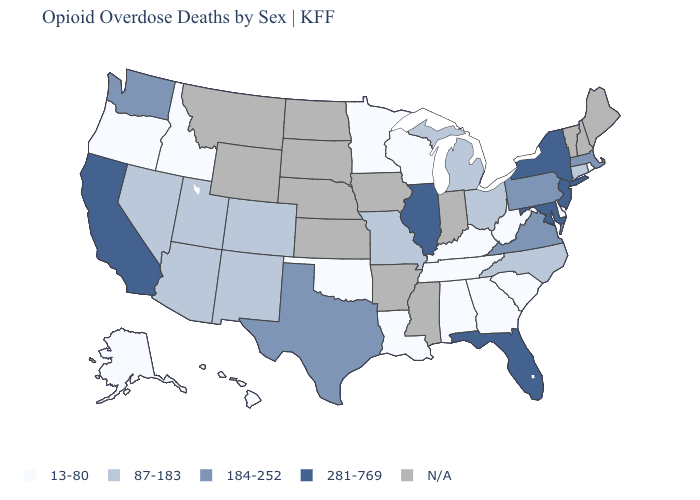What is the value of Minnesota?
Give a very brief answer. 13-80. How many symbols are there in the legend?
Write a very short answer. 5. What is the lowest value in the West?
Answer briefly. 13-80. Among the states that border New Jersey , which have the highest value?
Short answer required. New York. What is the highest value in the USA?
Short answer required. 281-769. What is the value of Arizona?
Keep it brief. 87-183. Name the states that have a value in the range 13-80?
Concise answer only. Alabama, Alaska, Delaware, Georgia, Hawaii, Idaho, Kentucky, Louisiana, Minnesota, Oklahoma, Oregon, Rhode Island, South Carolina, Tennessee, West Virginia, Wisconsin. Name the states that have a value in the range 184-252?
Short answer required. Massachusetts, Pennsylvania, Texas, Virginia, Washington. Name the states that have a value in the range N/A?
Quick response, please. Arkansas, Indiana, Iowa, Kansas, Maine, Mississippi, Montana, Nebraska, New Hampshire, North Dakota, South Dakota, Vermont, Wyoming. Does California have the highest value in the West?
Write a very short answer. Yes. What is the highest value in states that border Utah?
Keep it brief. 87-183. What is the highest value in the West ?
Be succinct. 281-769. Does the map have missing data?
Concise answer only. Yes. Is the legend a continuous bar?
Concise answer only. No. 